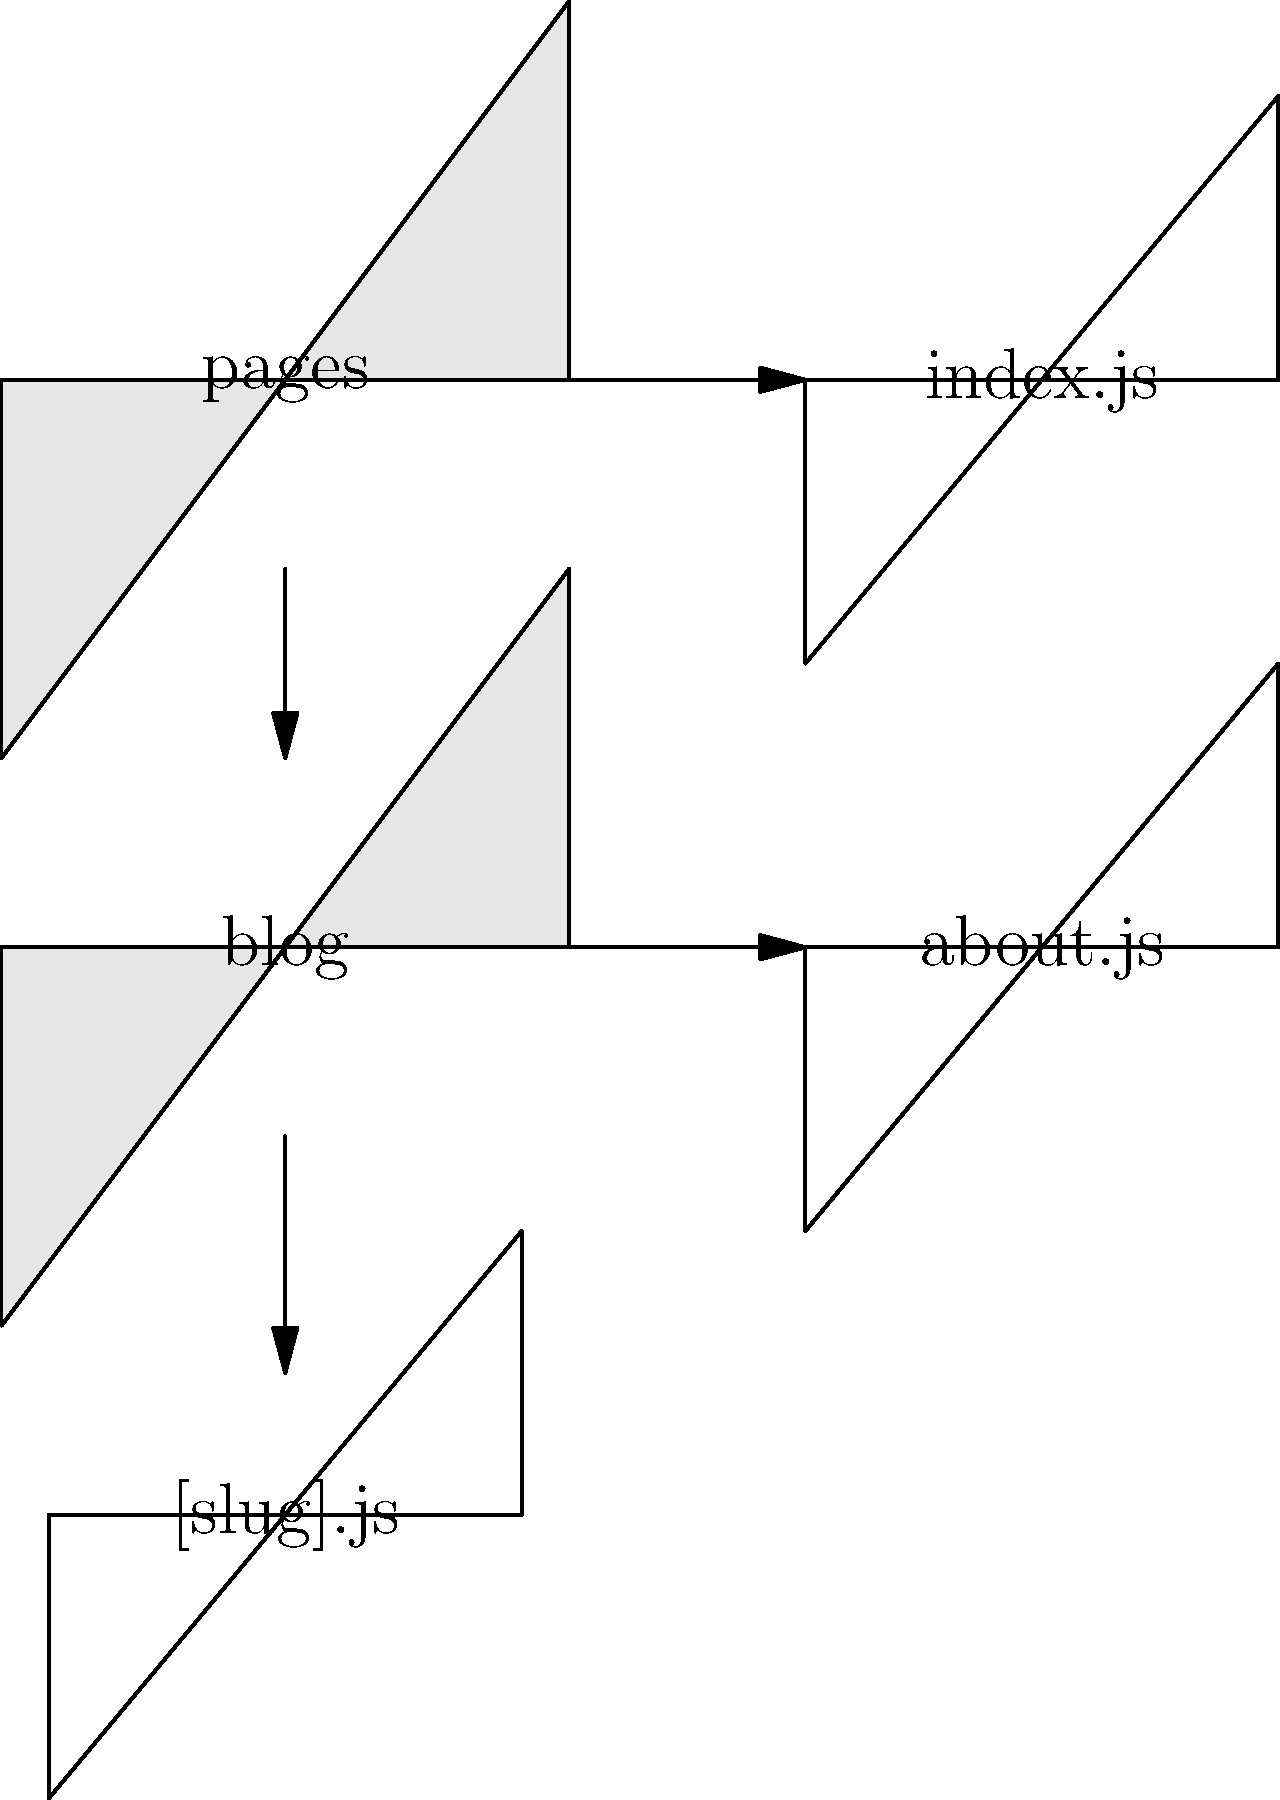Based on the Next.js file structure shown in the image, which URL path would correctly render the content of the [slug].js file for a blog post with the slug "my-first-post"? To determine the correct URL path for rendering the content of the [slug].js file, let's analyze the file structure step-by-step:

1. We see a "pages" folder at the root level, which is the standard directory for Next.js pages.
2. Inside the "pages" folder, there's a "blog" subfolder.
3. Within the "blog" subfolder, we find a [slug].js file.

In Next.js, the file structure directly corresponds to the URL routing:

- The "pages" folder represents the root of the website.
- Subfolders within "pages" create nested routes.
- Files named with square brackets, like [slug].js, represent dynamic routes.

Therefore, the URL structure for accessing a blog post would be:

/blog/[actual-slug]

For a blog post with the slug "my-first-post", the correct URL path would be:

/blog/my-first-post

This URL will render the content of the [slug].js file, with "my-first-post" available as the slug parameter in the page component.
Answer: /blog/my-first-post 